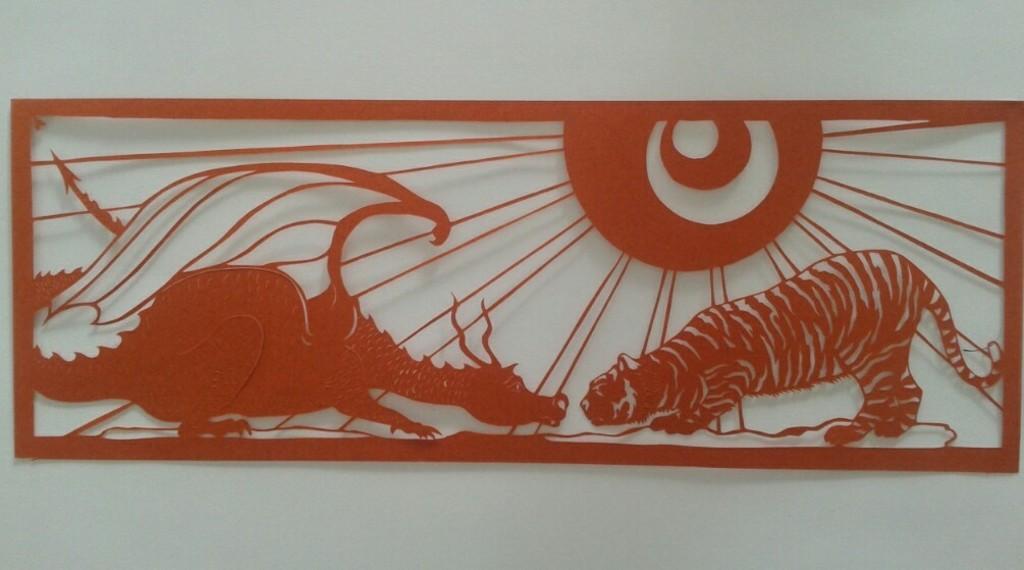Can you describe this image briefly? In this image, we can see a painting on a white color wall. 